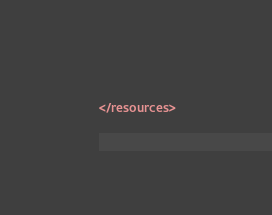Convert code to text. <code><loc_0><loc_0><loc_500><loc_500><_XML_></resources></code> 